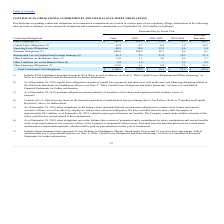According to Plexus's financial document, What does debt obligations include? $150.0 million in principal amount of 2018 Notes as well as interest. The document states: "1) Includes $150.0 million in principal amount of 2018 Notes as well as interest; see Note 4, "Debt, Capital Lease Obligations and Other Financing," i..." Also, What did capital lease obligations consist of as of September 28, 2019? capital lease payments and interest as well as the non-cash financing obligation related to the failed sale-leasebacks in Guadalajara, Mexico. The document states: "r 28, 2019, capital lease obligations consists of capital lease payments and interest as well as the non-cash financing obligation related to the fail..." Also, What were the total Operating Lease Obligations? According to the financial document, 40.8 (in millions). The relevant text states: "Operating Lease Obligations 40.8 10.4 12.2 8.8 9.4..." Also, can you calculate: What were the total debt obligations as a percentage of total contractual obligations? Based on the calculation: 288.3/1,206.6, the result is 23.89 (percentage). This is based on the information: "Total Contractual Cash Obligations $ 1,206.6 $ 732.0 $ 76.1 $ 51.5 $ 347.0 Debt Obligations (1) $ 288.3 $ 101.2 $ 12.4 $ 12.2 $ 162.5..." The key data points involved are: 1,206.6, 288.3. Also, can you calculate: What was the difference in the total between Other Liabilities on and not on the Balance Sheet? Based on the calculation: 15.0-8.6, the result is 6.4 (in millions). This is based on the information: "Other Liabilities not on the Balance Sheet (6) 8.6 1.8 — 1.3 5.5 Other Liabilities on the Balance Sheet (5) 15.0 3.3 4.0 0.6 7.1..." The key data points involved are: 15.0, 8.6. Also, can you calculate: What was the difference in the total between  Repatriation Tax on Undistributed Foreign Earnings and Purchase Obligations? Based on the calculation: 620.0-65.1, the result is 554.9 (in millions). This is based on the information: "riation Tax on Undistributed Foreign Earnings (4) 65.1 5.5 11.4 16.3 31.9 Purchase Obligations (3) 620.0 598.8 20.7 0.4 0.1..." The key data points involved are: 620.0, 65.1. 